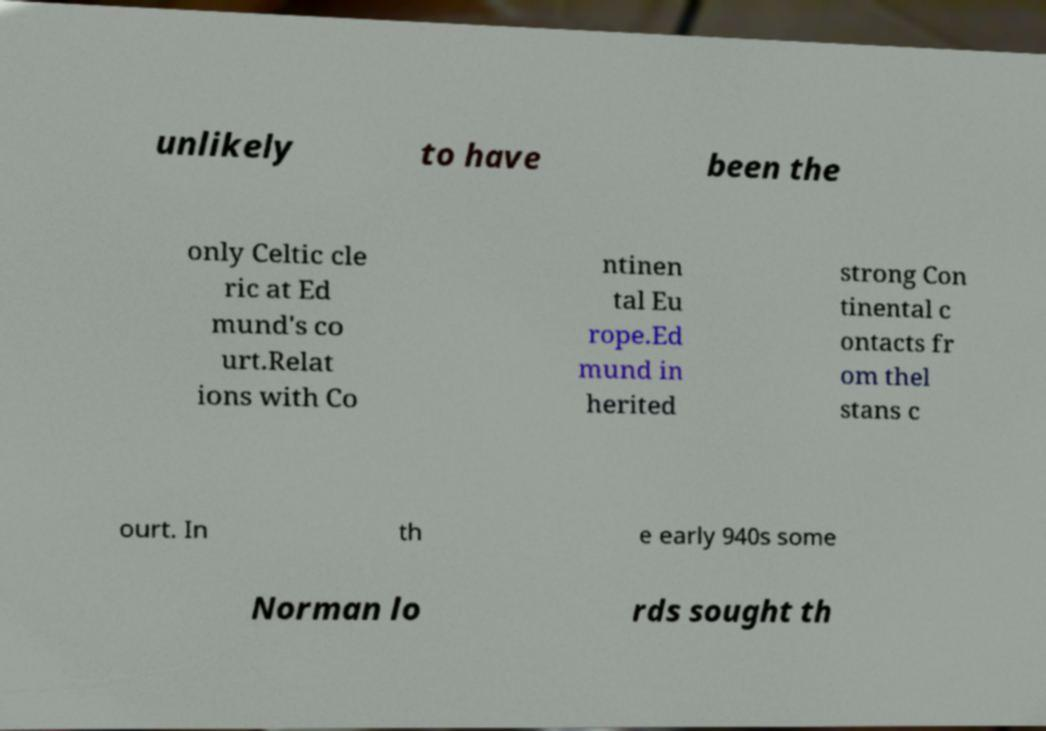Could you extract and type out the text from this image? unlikely to have been the only Celtic cle ric at Ed mund's co urt.Relat ions with Co ntinen tal Eu rope.Ed mund in herited strong Con tinental c ontacts fr om thel stans c ourt. In th e early 940s some Norman lo rds sought th 